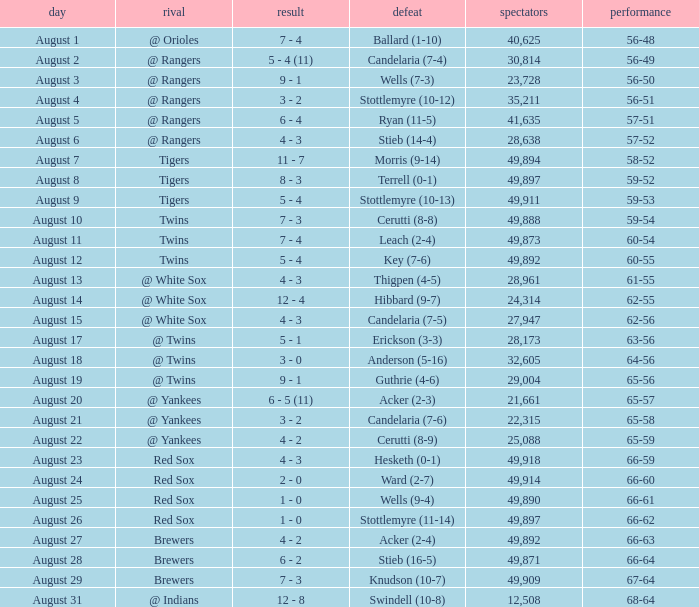What was the record of the game that had a loss of Stottlemyre (10-12)? 56-51. 